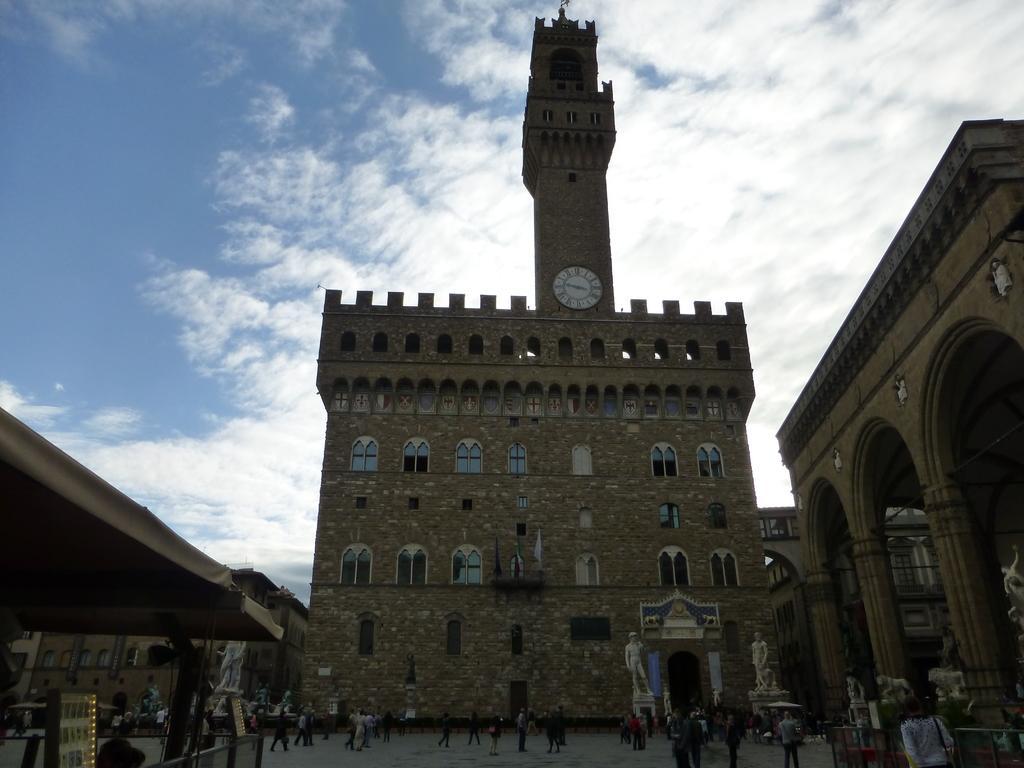Please provide a concise description of this image. In the center of the image there are buildings. At the bottom we can see statues and there are many people walking. At the top there is sky. On the left there is a tent. 